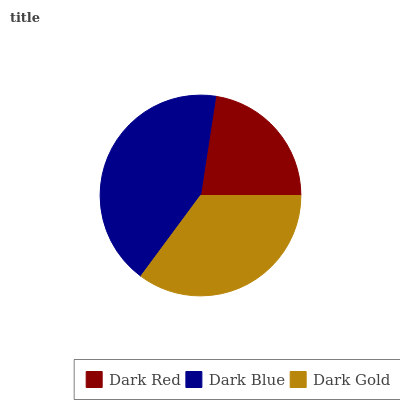Is Dark Red the minimum?
Answer yes or no. Yes. Is Dark Blue the maximum?
Answer yes or no. Yes. Is Dark Gold the minimum?
Answer yes or no. No. Is Dark Gold the maximum?
Answer yes or no. No. Is Dark Blue greater than Dark Gold?
Answer yes or no. Yes. Is Dark Gold less than Dark Blue?
Answer yes or no. Yes. Is Dark Gold greater than Dark Blue?
Answer yes or no. No. Is Dark Blue less than Dark Gold?
Answer yes or no. No. Is Dark Gold the high median?
Answer yes or no. Yes. Is Dark Gold the low median?
Answer yes or no. Yes. Is Dark Red the high median?
Answer yes or no. No. Is Dark Blue the low median?
Answer yes or no. No. 